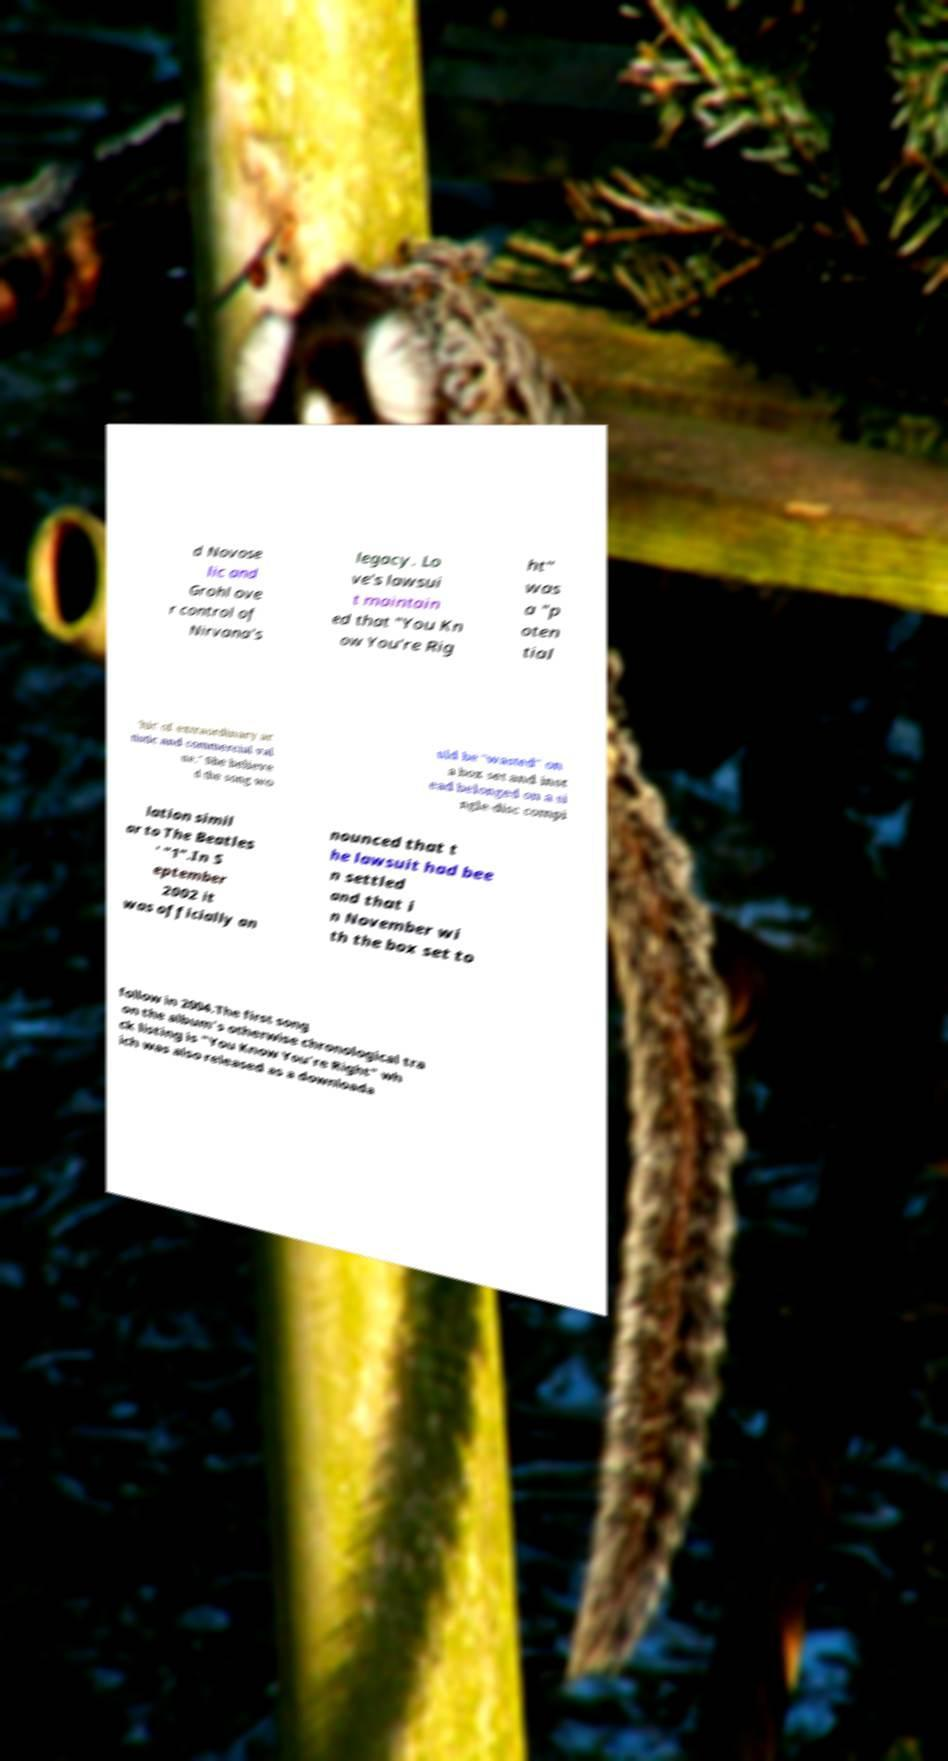What messages or text are displayed in this image? I need them in a readable, typed format. d Novose lic and Grohl ove r control of Nirvana's legacy. Lo ve's lawsui t maintain ed that "You Kn ow You're Rig ht" was a "p oten tial 'hit' of extraordinary ar tistic and commercial val ue." She believe d the song wo uld be "wasted" on a box set and inst ead belonged on a si ngle-disc compi lation simil ar to The Beatles ' "1".In S eptember 2002 it was officially an nounced that t he lawsuit had bee n settled and that i n November wi th the box set to follow in 2004.The first song on the album's otherwise chronological tra ck listing is "You Know You're Right" wh ich was also released as a downloada 